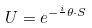Convert formula to latex. <formula><loc_0><loc_0><loc_500><loc_500>U = e ^ { - \frac { i } { } \theta \cdot S }</formula> 